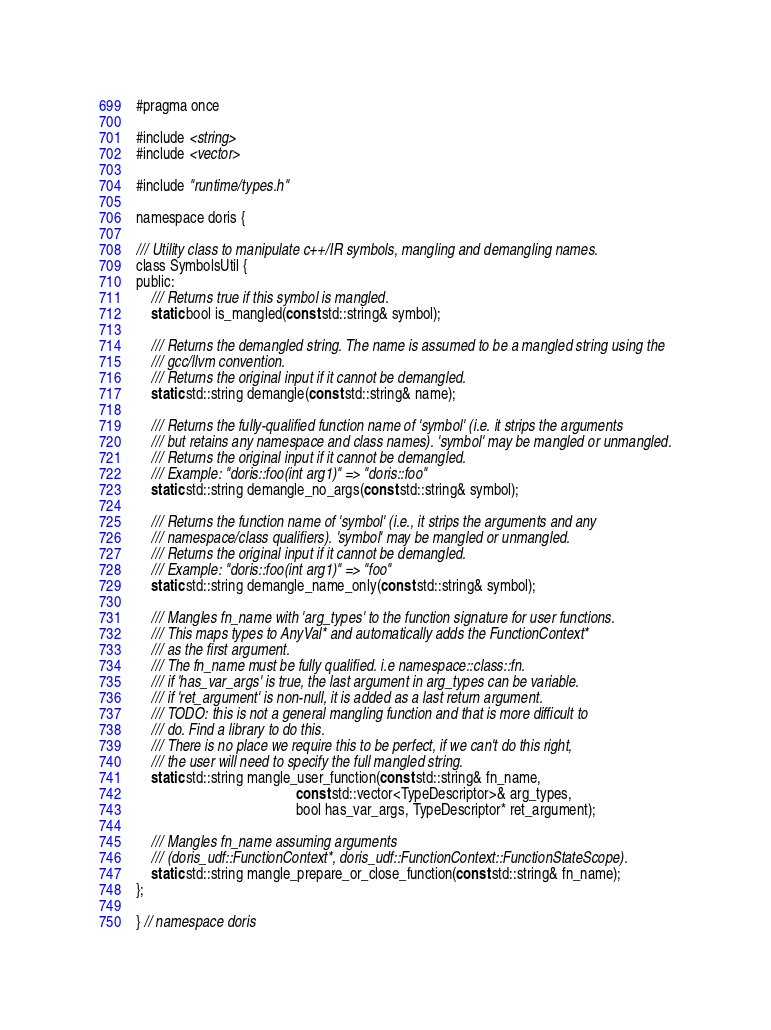<code> <loc_0><loc_0><loc_500><loc_500><_C_>#pragma once

#include <string>
#include <vector>

#include "runtime/types.h"

namespace doris {

/// Utility class to manipulate c++/IR symbols, mangling and demangling names.
class SymbolsUtil {
public:
    /// Returns true if this symbol is mangled.
    static bool is_mangled(const std::string& symbol);

    /// Returns the demangled string. The name is assumed to be a mangled string using the
    /// gcc/llvm convention.
    /// Returns the original input if it cannot be demangled.
    static std::string demangle(const std::string& name);

    /// Returns the fully-qualified function name of 'symbol' (i.e. it strips the arguments
    /// but retains any namespace and class names). 'symbol' may be mangled or unmangled.
    /// Returns the original input if it cannot be demangled.
    /// Example: "doris::foo(int arg1)" => "doris::foo"
    static std::string demangle_no_args(const std::string& symbol);

    /// Returns the function name of 'symbol' (i.e., it strips the arguments and any
    /// namespace/class qualifiers). 'symbol' may be mangled or unmangled.
    /// Returns the original input if it cannot be demangled.
    /// Example: "doris::foo(int arg1)" => "foo"
    static std::string demangle_name_only(const std::string& symbol);

    /// Mangles fn_name with 'arg_types' to the function signature for user functions.
    /// This maps types to AnyVal* and automatically adds the FunctionContext*
    /// as the first argument.
    /// The fn_name must be fully qualified. i.e namespace::class::fn.
    /// if 'has_var_args' is true, the last argument in arg_types can be variable.
    /// if 'ret_argument' is non-null, it is added as a last return argument.
    /// TODO: this is not a general mangling function and that is more difficult to
    /// do. Find a library to do this.
    /// There is no place we require this to be perfect, if we can't do this right,
    /// the user will need to specify the full mangled string.
    static std::string mangle_user_function(const std::string& fn_name,
                                            const std::vector<TypeDescriptor>& arg_types,
                                            bool has_var_args, TypeDescriptor* ret_argument);

    /// Mangles fn_name assuming arguments
    /// (doris_udf::FunctionContext*, doris_udf::FunctionContext::FunctionStateScope).
    static std::string mangle_prepare_or_close_function(const std::string& fn_name);
};

} // namespace doris
</code> 